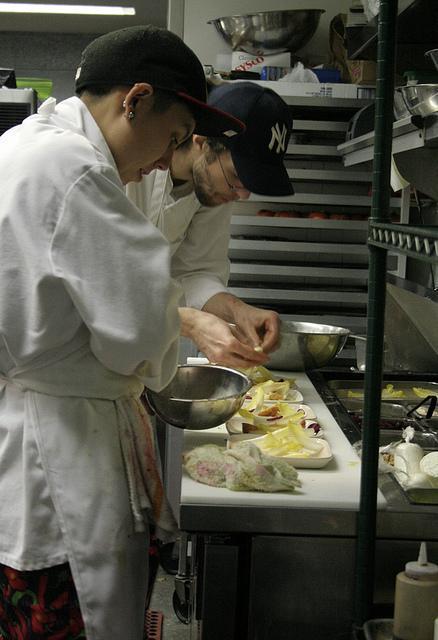How many bowls are there?
Give a very brief answer. 2. How many people are visible?
Give a very brief answer. 2. 